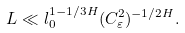Convert formula to latex. <formula><loc_0><loc_0><loc_500><loc_500>L \ll l _ { 0 } ^ { 1 - 1 / 3 H } ( C ^ { 2 } _ { \varepsilon } ) ^ { - 1 / 2 H } .</formula> 